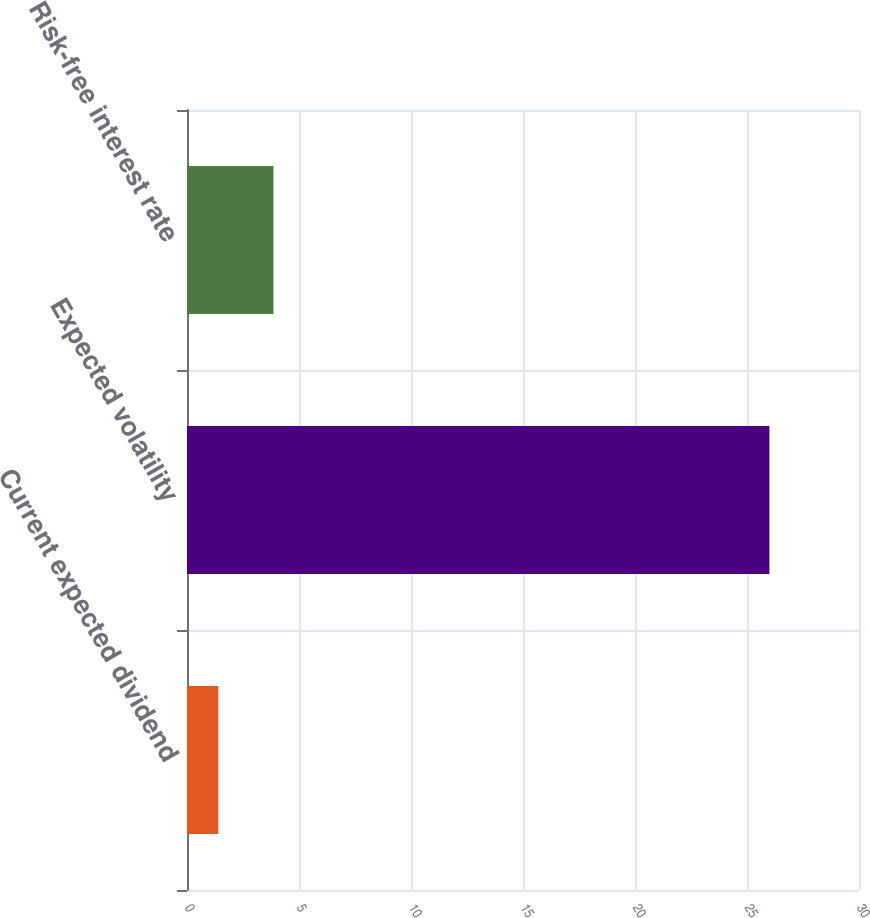Convert chart. <chart><loc_0><loc_0><loc_500><loc_500><bar_chart><fcel>Current expected dividend<fcel>Expected volatility<fcel>Risk-free interest rate<nl><fcel>1.4<fcel>26<fcel>3.86<nl></chart> 